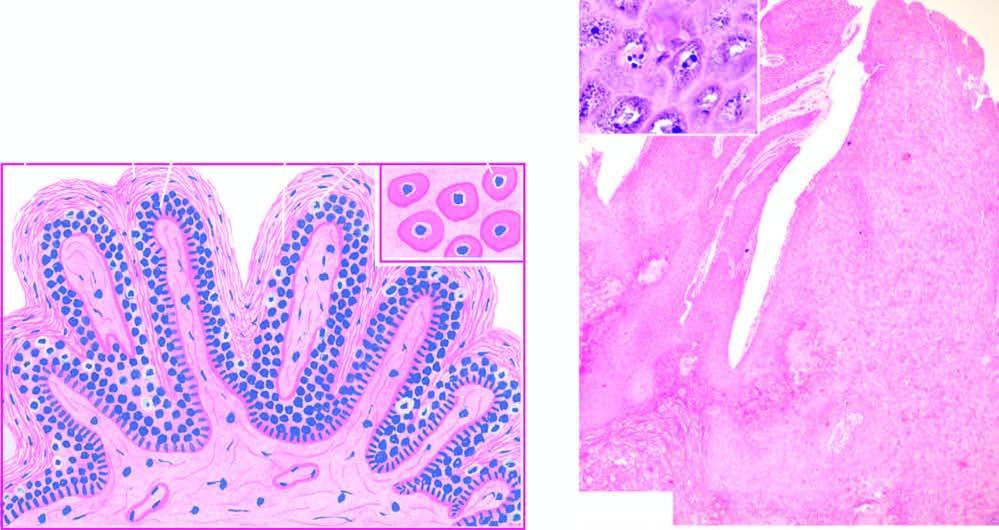does its wall show koilocytes and virus-infected keratinocytes containing prominent keratohyaline granules?
Answer the question using a single word or phrase. No 